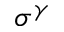Convert formula to latex. <formula><loc_0><loc_0><loc_500><loc_500>\sigma ^ { \gamma }</formula> 